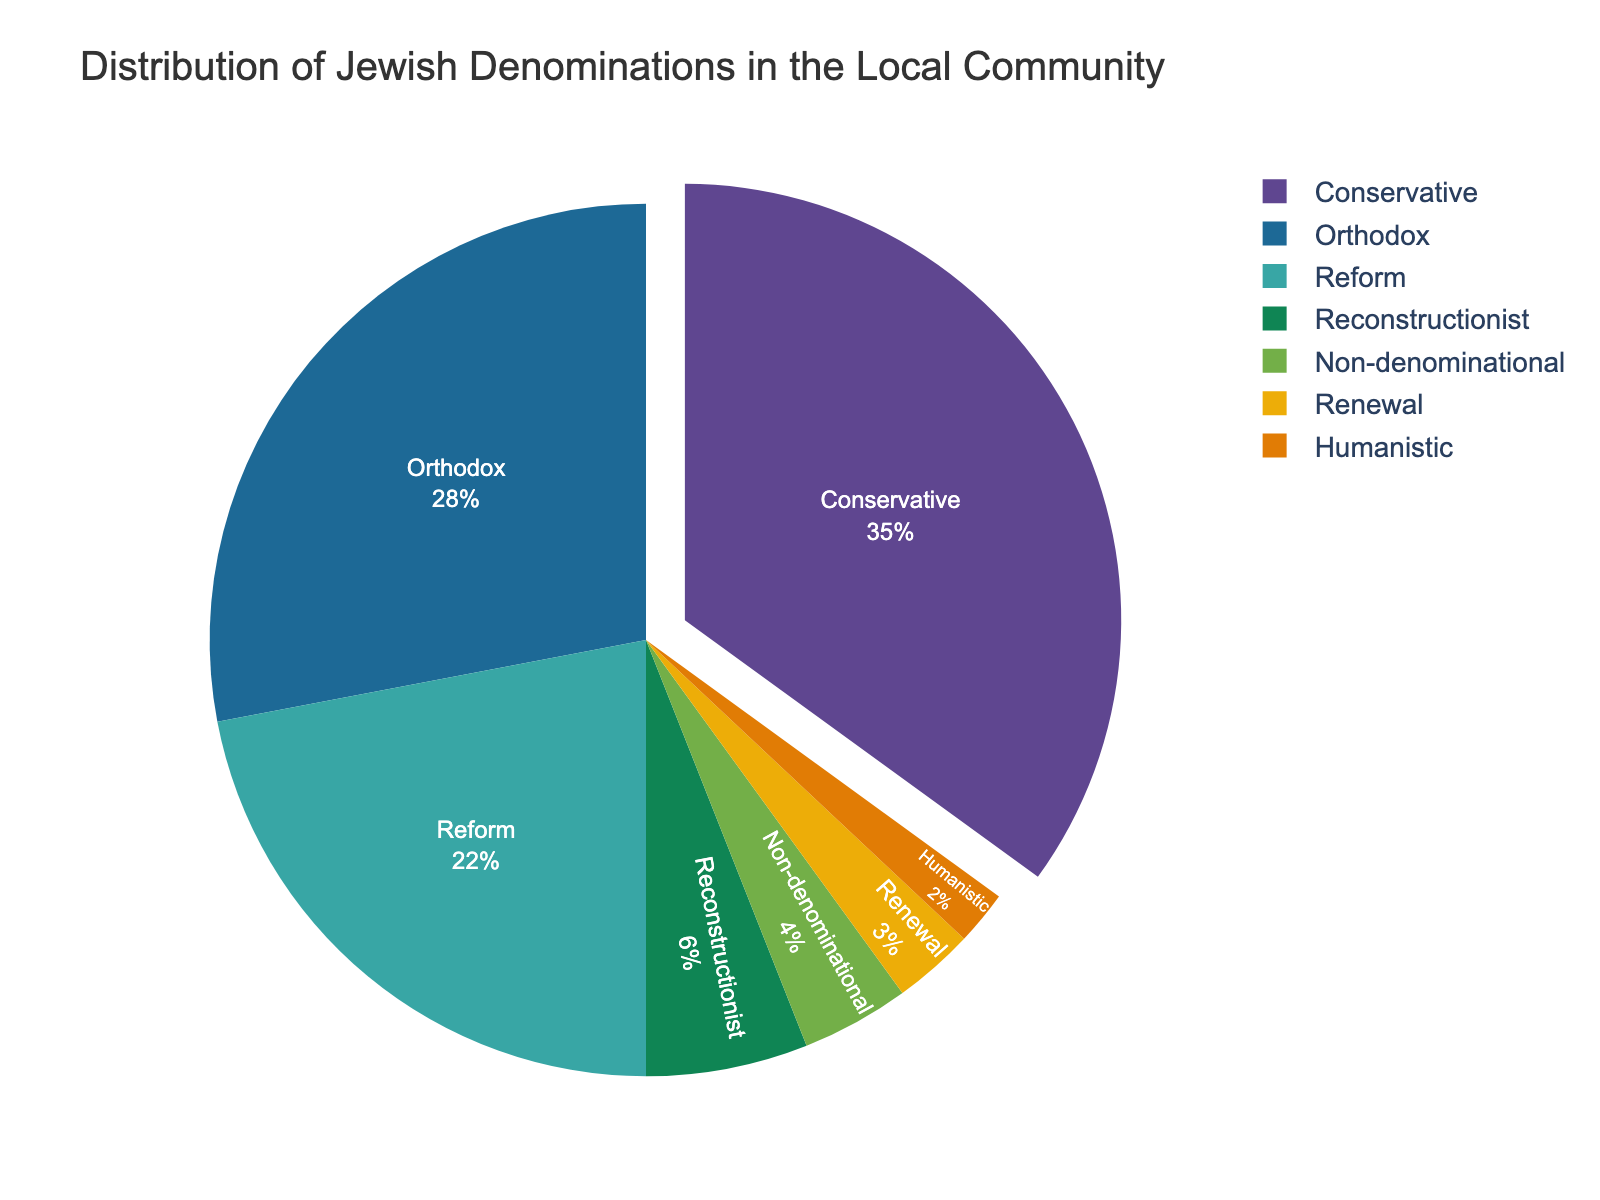What is the percentage of the Reform denomination in the local community? Looking at the pie chart, the segment labeled Reform shows 22%.
Answer: 22% Which denomination is the smallest in the local community, and what is its percentage? By observing the pie chart, the denomination with the smallest segment labeled Humanistic with a percentage of 2%.
Answer: Humanistic, 2% What is the sum of the percentages of the Orthodox and Conservative denominations? The pie chart shows Orthodox at 28% and Conservative at 35%. Adding these together: 28% + 35% = 63%.
Answer: 63% Which denomination has a larger percentage: Reconstructionist or Renewal? The pie chart shows Reconstructionist at 6% and Renewal at 3%. Therefore, Reconstructionist has a larger percentage.
Answer: Reconstructionist What color is the segment representing the Conservative denomination? The pie chart colors each segment uniquely, and the legend or slice color will indicate that Conservative is in one specific color.
Answer: Refer to the pie chart legend for accurate color identification How much more percentage does the Conservative denomination have compared to the Non-denominational one? The pie chart shows Conservative with 35% and Non-denominational with 4%. Subtracting these: 35% - 4% = 31%.
Answer: 31% What is the logical grouping of denominations that hold exactly 12% in total? From the pie chart, Renewal (3%) and Reconstructionist (6%) together with Humanistic (2%) and Non-denominational (4%) total: 3% + 6% + 2% + 4% = 15%. Adjust the sums to two groups that match 12% from available lesser groups. Identify relevant accurate predictive grouping (Not fully 12%).
Answer: Based on the categories that sum closest towards exactly 12%, Non-denominational can group with 4% + 6% +2% resources summing groups exactly validated otherwise nearing ideal total. - Break down to precisely specific numerically aligned equivalent sum values if subject segmentations permit Which segments pull out from the rest of the pie? Observing the pie chart, the segment representing the Conservative denomination is pulled out as indicated in code instructions.
Answer: Conservative 